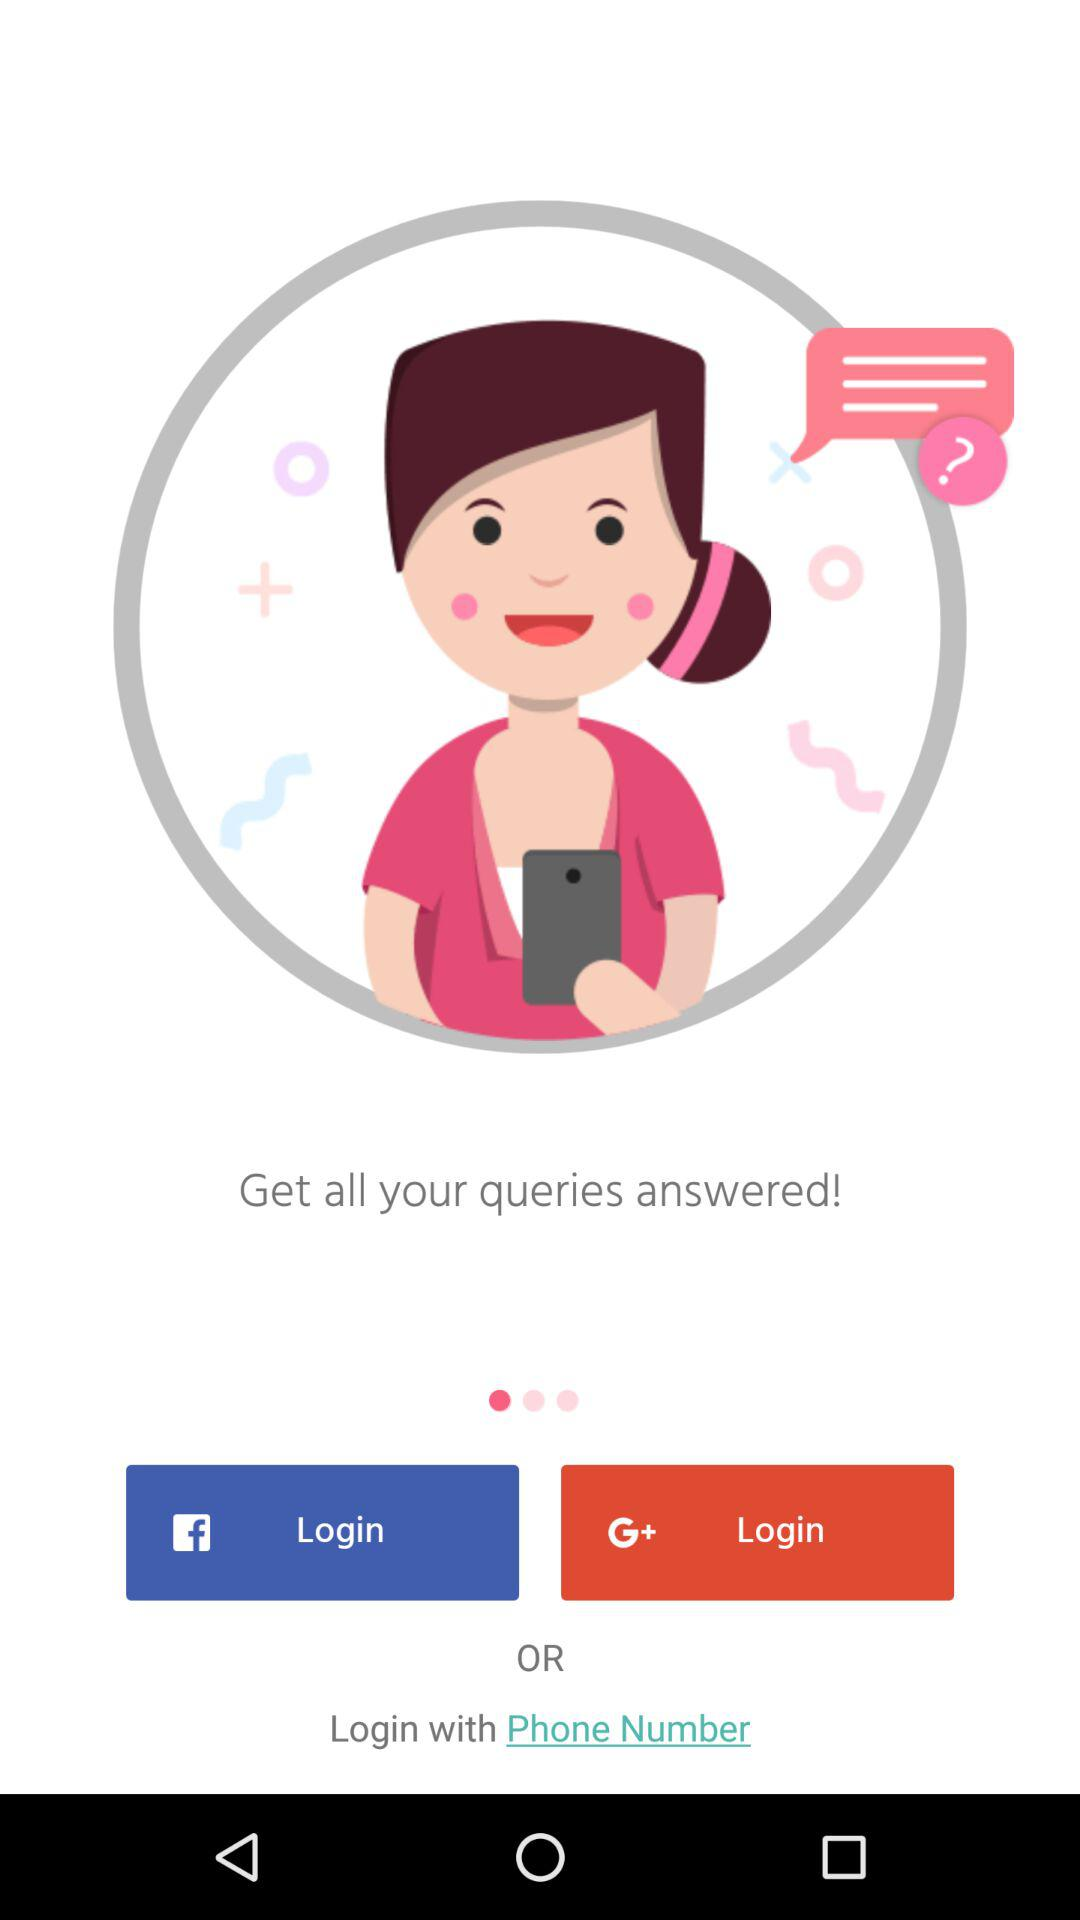Which are the different login options? The different login options are "Facebook", "Google+" and "Phone Number". 